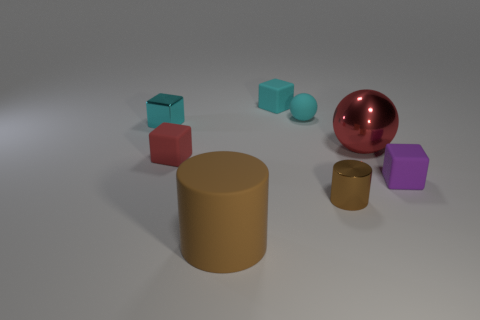What shape is the red thing that is the same material as the large brown thing?
Keep it short and to the point. Cube. What is the material of the thing that is in front of the tiny metal object in front of the purple matte block?
Offer a terse response. Rubber. Is the shape of the cyan metallic thing behind the large metallic sphere the same as  the red matte object?
Your answer should be compact. Yes. Is the number of tiny balls that are on the left side of the tiny brown cylinder greater than the number of large green matte balls?
Provide a succinct answer. Yes. What is the shape of the other thing that is the same color as the big matte object?
Ensure brevity in your answer.  Cylinder. What number of blocks are large cyan rubber objects or cyan things?
Keep it short and to the point. 2. There is a large object in front of the red object left of the large metal ball; what color is it?
Make the answer very short. Brown. There is a small metal cube; is it the same color as the small rubber block on the right side of the small ball?
Your answer should be compact. No. The brown thing that is made of the same material as the tiny red object is what size?
Provide a succinct answer. Large. There is a thing that is the same color as the large metallic sphere; what size is it?
Your response must be concise. Small. 